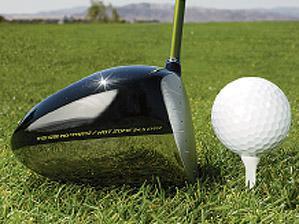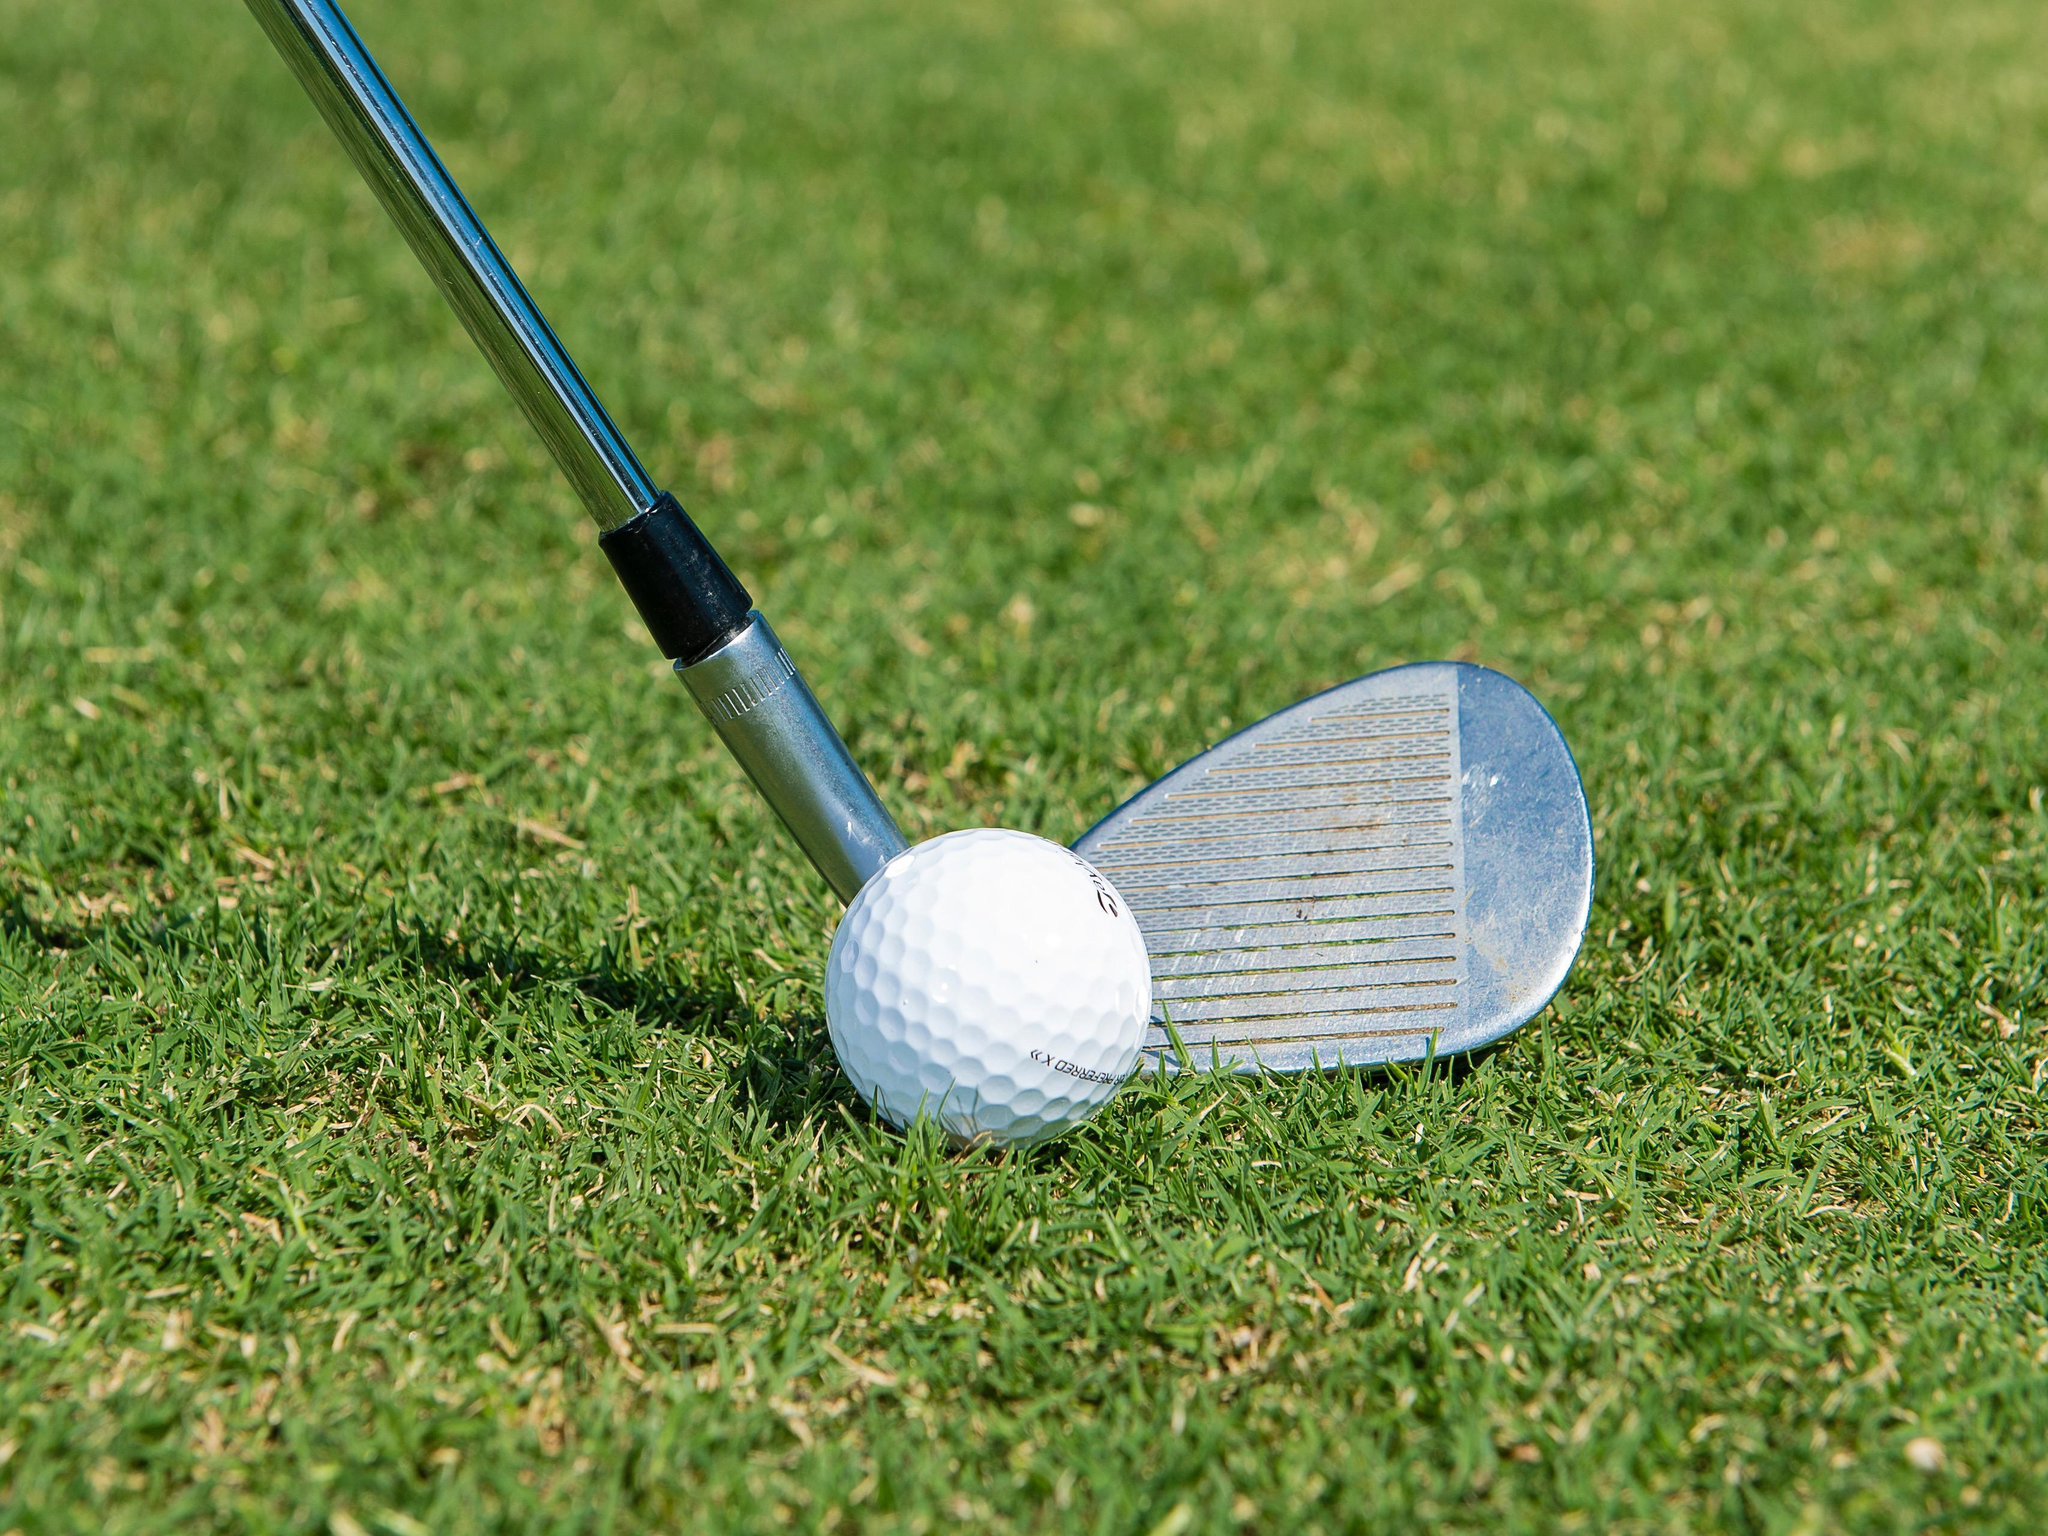The first image is the image on the left, the second image is the image on the right. Analyze the images presented: Is the assertion "The golf ball in the left image is on a tee." valid? Answer yes or no. Yes. 